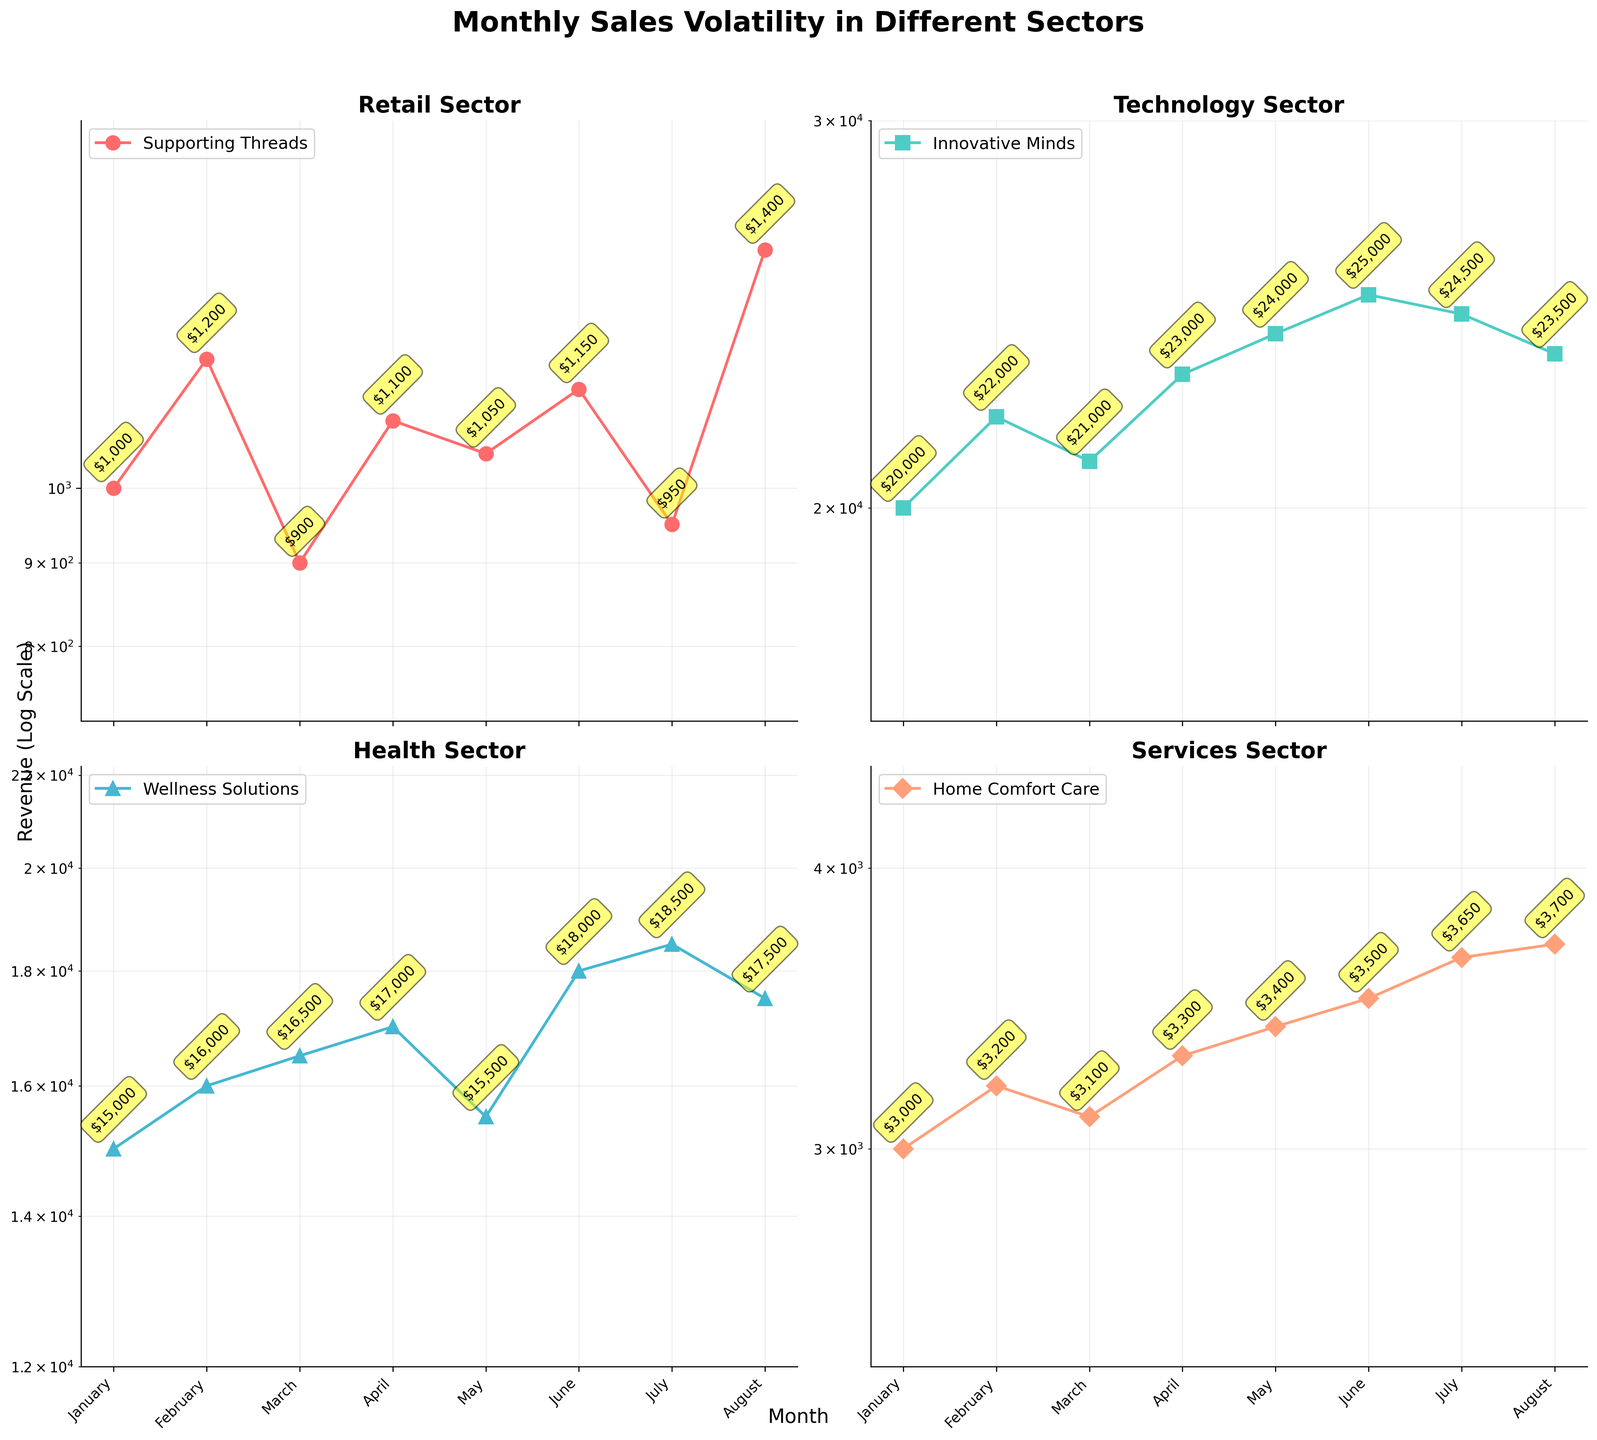What's the title of the figure? The title of the figure is displayed prominently above the subplots in large, bold font.
Answer: Monthly Sales Volatility in Different Sectors Which sector shows the largest fluctuation in revenue? By observing the range between the minimum and maximum revenue on each subplot, the Retail sector shows the largest fluctuations in revenue. The revenue ranges from $900 to $1400.
Answer: Retail What is the maximum revenue for the Technology sector? The Technology subplot shows a peak revenue point annotated at $25,000 in the month of June.
Answer: $25,000 Between which two consecutive months does the Health sector show a decrease in revenue? Observing the Health subplot, the revenue drops from $17,000 in April to $15,500 in May.
Answer: April to May Which company represents the Services sector in the figure? Each subplot has a legend, with the Services sector legend indicating "Home Comfort Care" as the representing company.
Answer: Home Comfort Care How does the average revenue for the Health sector compare to the average revenue for the Services sector? First, sum the monthly revenues for each sector and then divide by the number of months (8 months). Health: (15000 + 16000 + 16500 + 17000 + 15500 + 18000 + 18500 + 17500) / 8 = 16750. Services: (3000 + 3200 + 3100 + 3300 + 3400 + 3500 + 3650 + 3700) / 8 = 3356.25. Therefore, the average revenue for the Health sector is significantly higher than that for the Services sector.
Answer: Health sector average is higher In the Retail sector, in which month is the revenue the lowest? On the Retail subplot, the annotated revenue values indicate the lowest revenue of $900 in March.
Answer: March What color represents the Health sector in the subplots? Each subplot uses a unique color, with the Health sector subplot using a turquoise-like color.
Answer: Turquoise-like How many months have revenues above $2,000 but below $10,000 in all subplots combined? Checking each subplot for the revenue annotations within the given range, only the Retail and Services sectors can be considered due to their revenue scales. In Retail (March, July) and Services (January, February, March, April, May, June, July, August) meet the criteria. In total, there are 10 months.
Answer: 10 months 